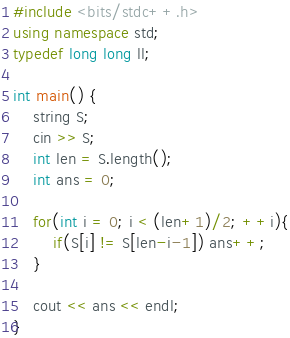Convert code to text. <code><loc_0><loc_0><loc_500><loc_500><_C++_>#include <bits/stdc++.h>
using namespace std;
typedef long long ll;

int main() {
    string S;
    cin >> S;
    int len = S.length();
    int ans = 0;

    for(int i = 0; i < (len+1)/2; ++i){
        if(S[i] != S[len-i-1]) ans++;
    }

    cout << ans << endl;
}</code> 